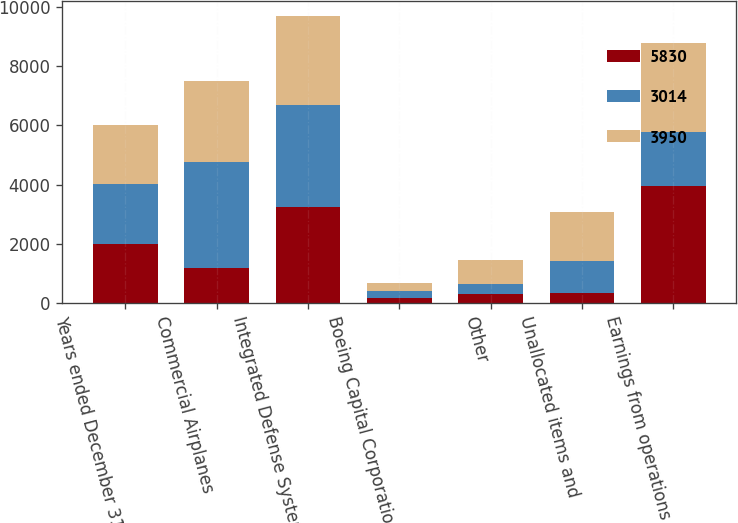Convert chart to OTSL. <chart><loc_0><loc_0><loc_500><loc_500><stacked_bar_chart><ecel><fcel>Years ended December 31<fcel>Commercial Airplanes<fcel>Integrated Defense Systems<fcel>Boeing Capital Corporation<fcel>Other<fcel>Unallocated items and<fcel>Earnings from operations<nl><fcel>5830<fcel>2008<fcel>1186<fcel>3232<fcel>162<fcel>307<fcel>323<fcel>3950<nl><fcel>3014<fcel>2007<fcel>3584<fcel>3440<fcel>234<fcel>331<fcel>1097<fcel>1831.5<nl><fcel>3950<fcel>2006<fcel>2733<fcel>3031<fcel>291<fcel>813<fcel>1657<fcel>3014<nl></chart> 